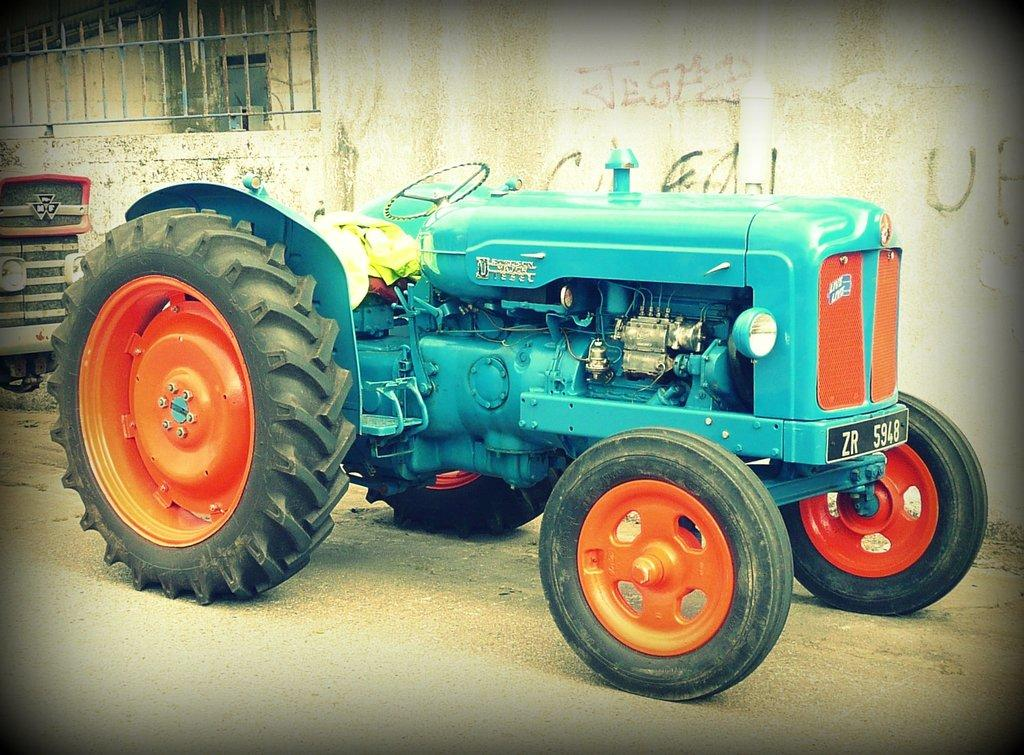What is the main subject in the image? There is a tractor on the road in the image. What can be seen in the background of the image? The front part of a vehicle, texts written on a wall, a fence, and other objects are present in the background of the image. Can you describe the wall in the background? The wall in the background has texts written on it. What is the purpose of the fence in the background? The fence in the background serves as a boundary or barrier. How many fish are swimming in the window in the image? There are no fish or windows present in the image. 